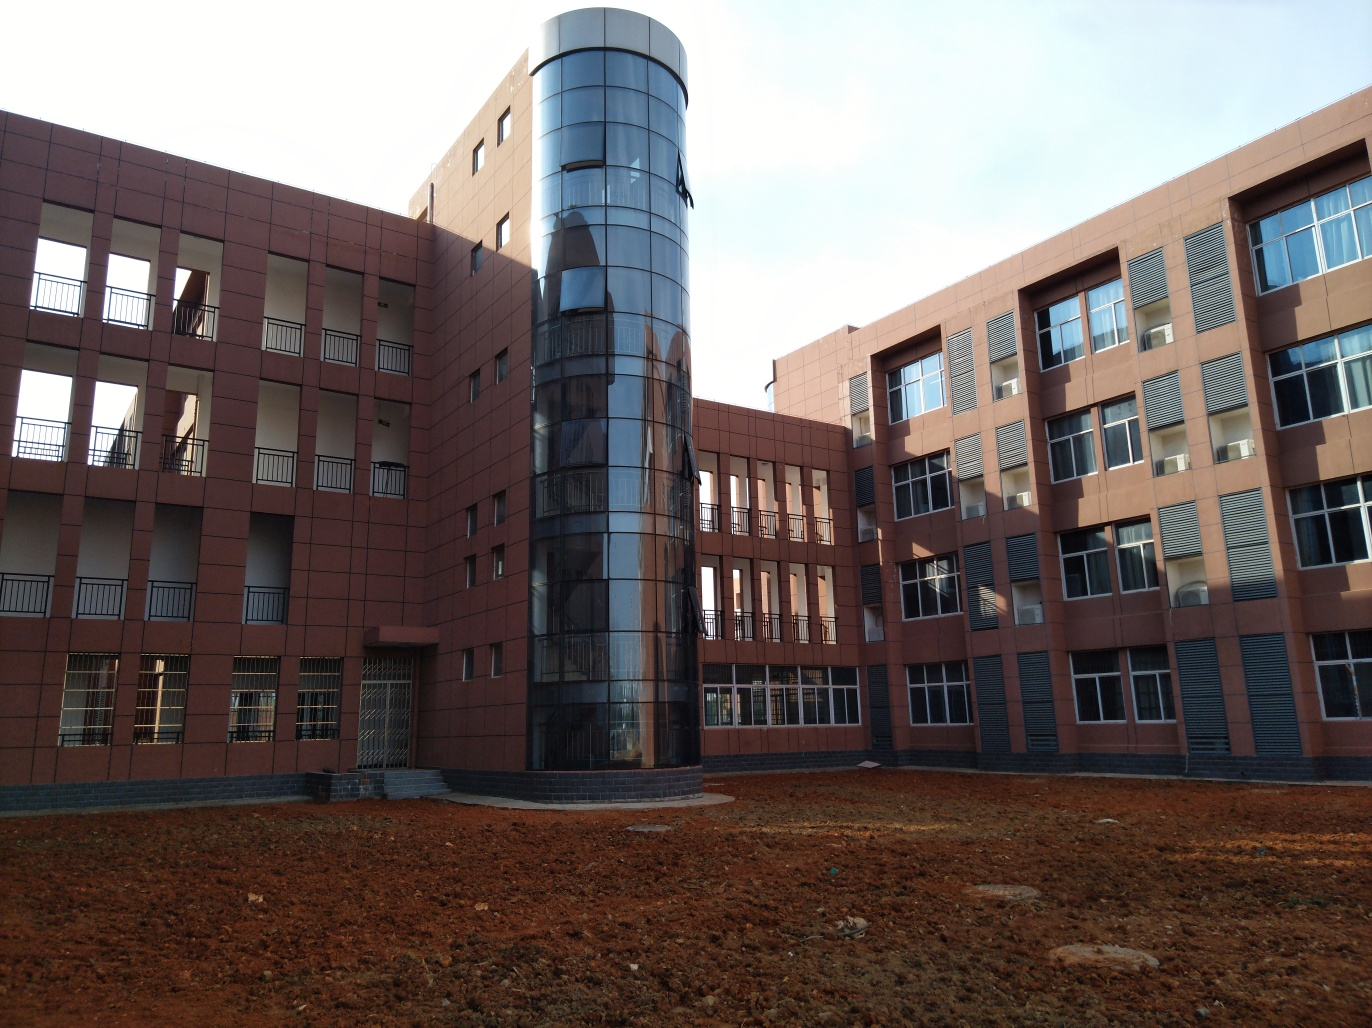Are there any focus issues in the photo? The photo appears to be well-focused, with the details on the buildings' facades, windows, and the cylindrical structure on the right being sharp and clear. There are no apparent signs of blurriness or softness that would indicate focus issues. 